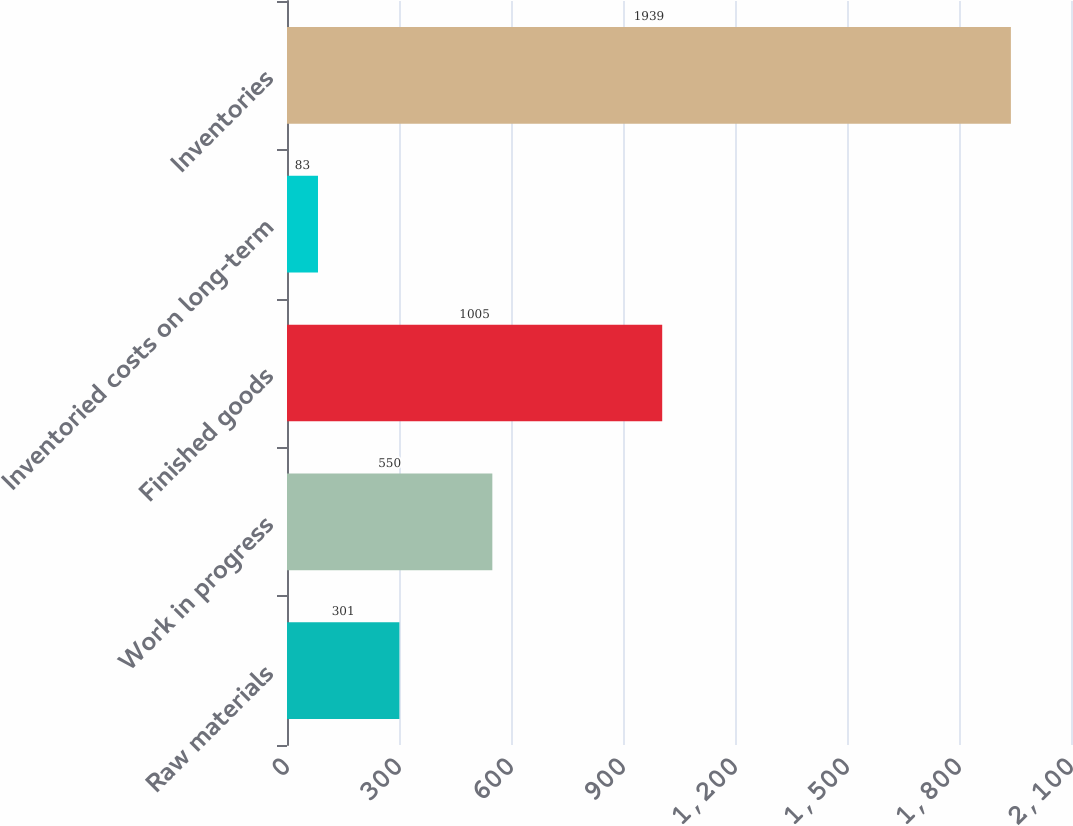Convert chart. <chart><loc_0><loc_0><loc_500><loc_500><bar_chart><fcel>Raw materials<fcel>Work in progress<fcel>Finished goods<fcel>Inventoried costs on long-term<fcel>Inventories<nl><fcel>301<fcel>550<fcel>1005<fcel>83<fcel>1939<nl></chart> 